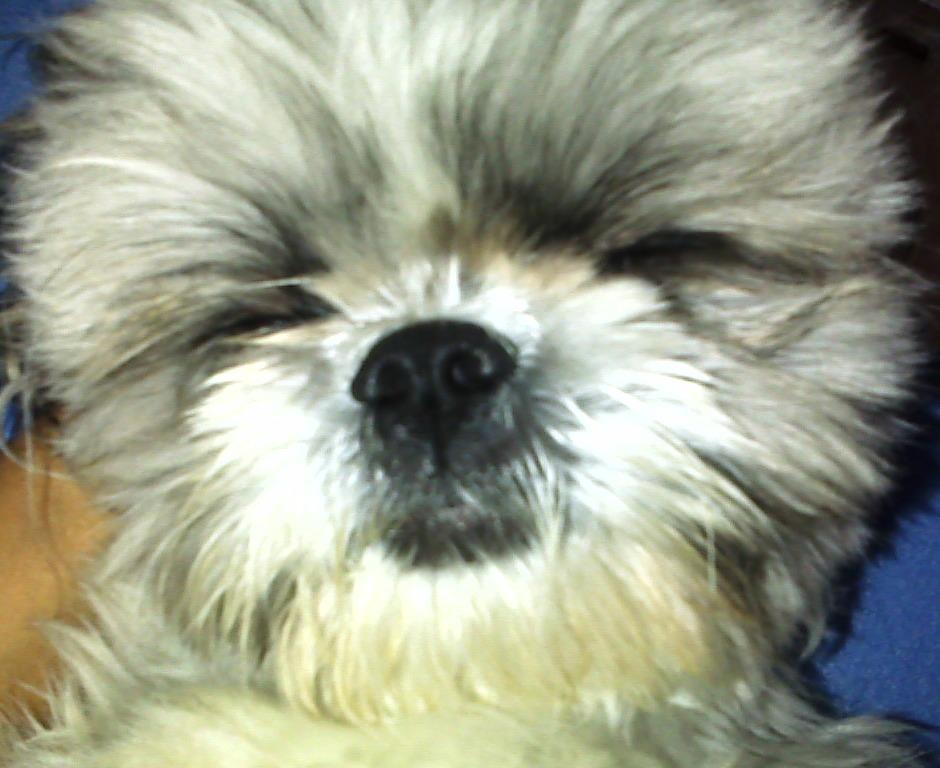How would you summarize this image in a sentence or two? In this image I can see the dog which is in white, cream and black color. And there is a blue and brown color background. 